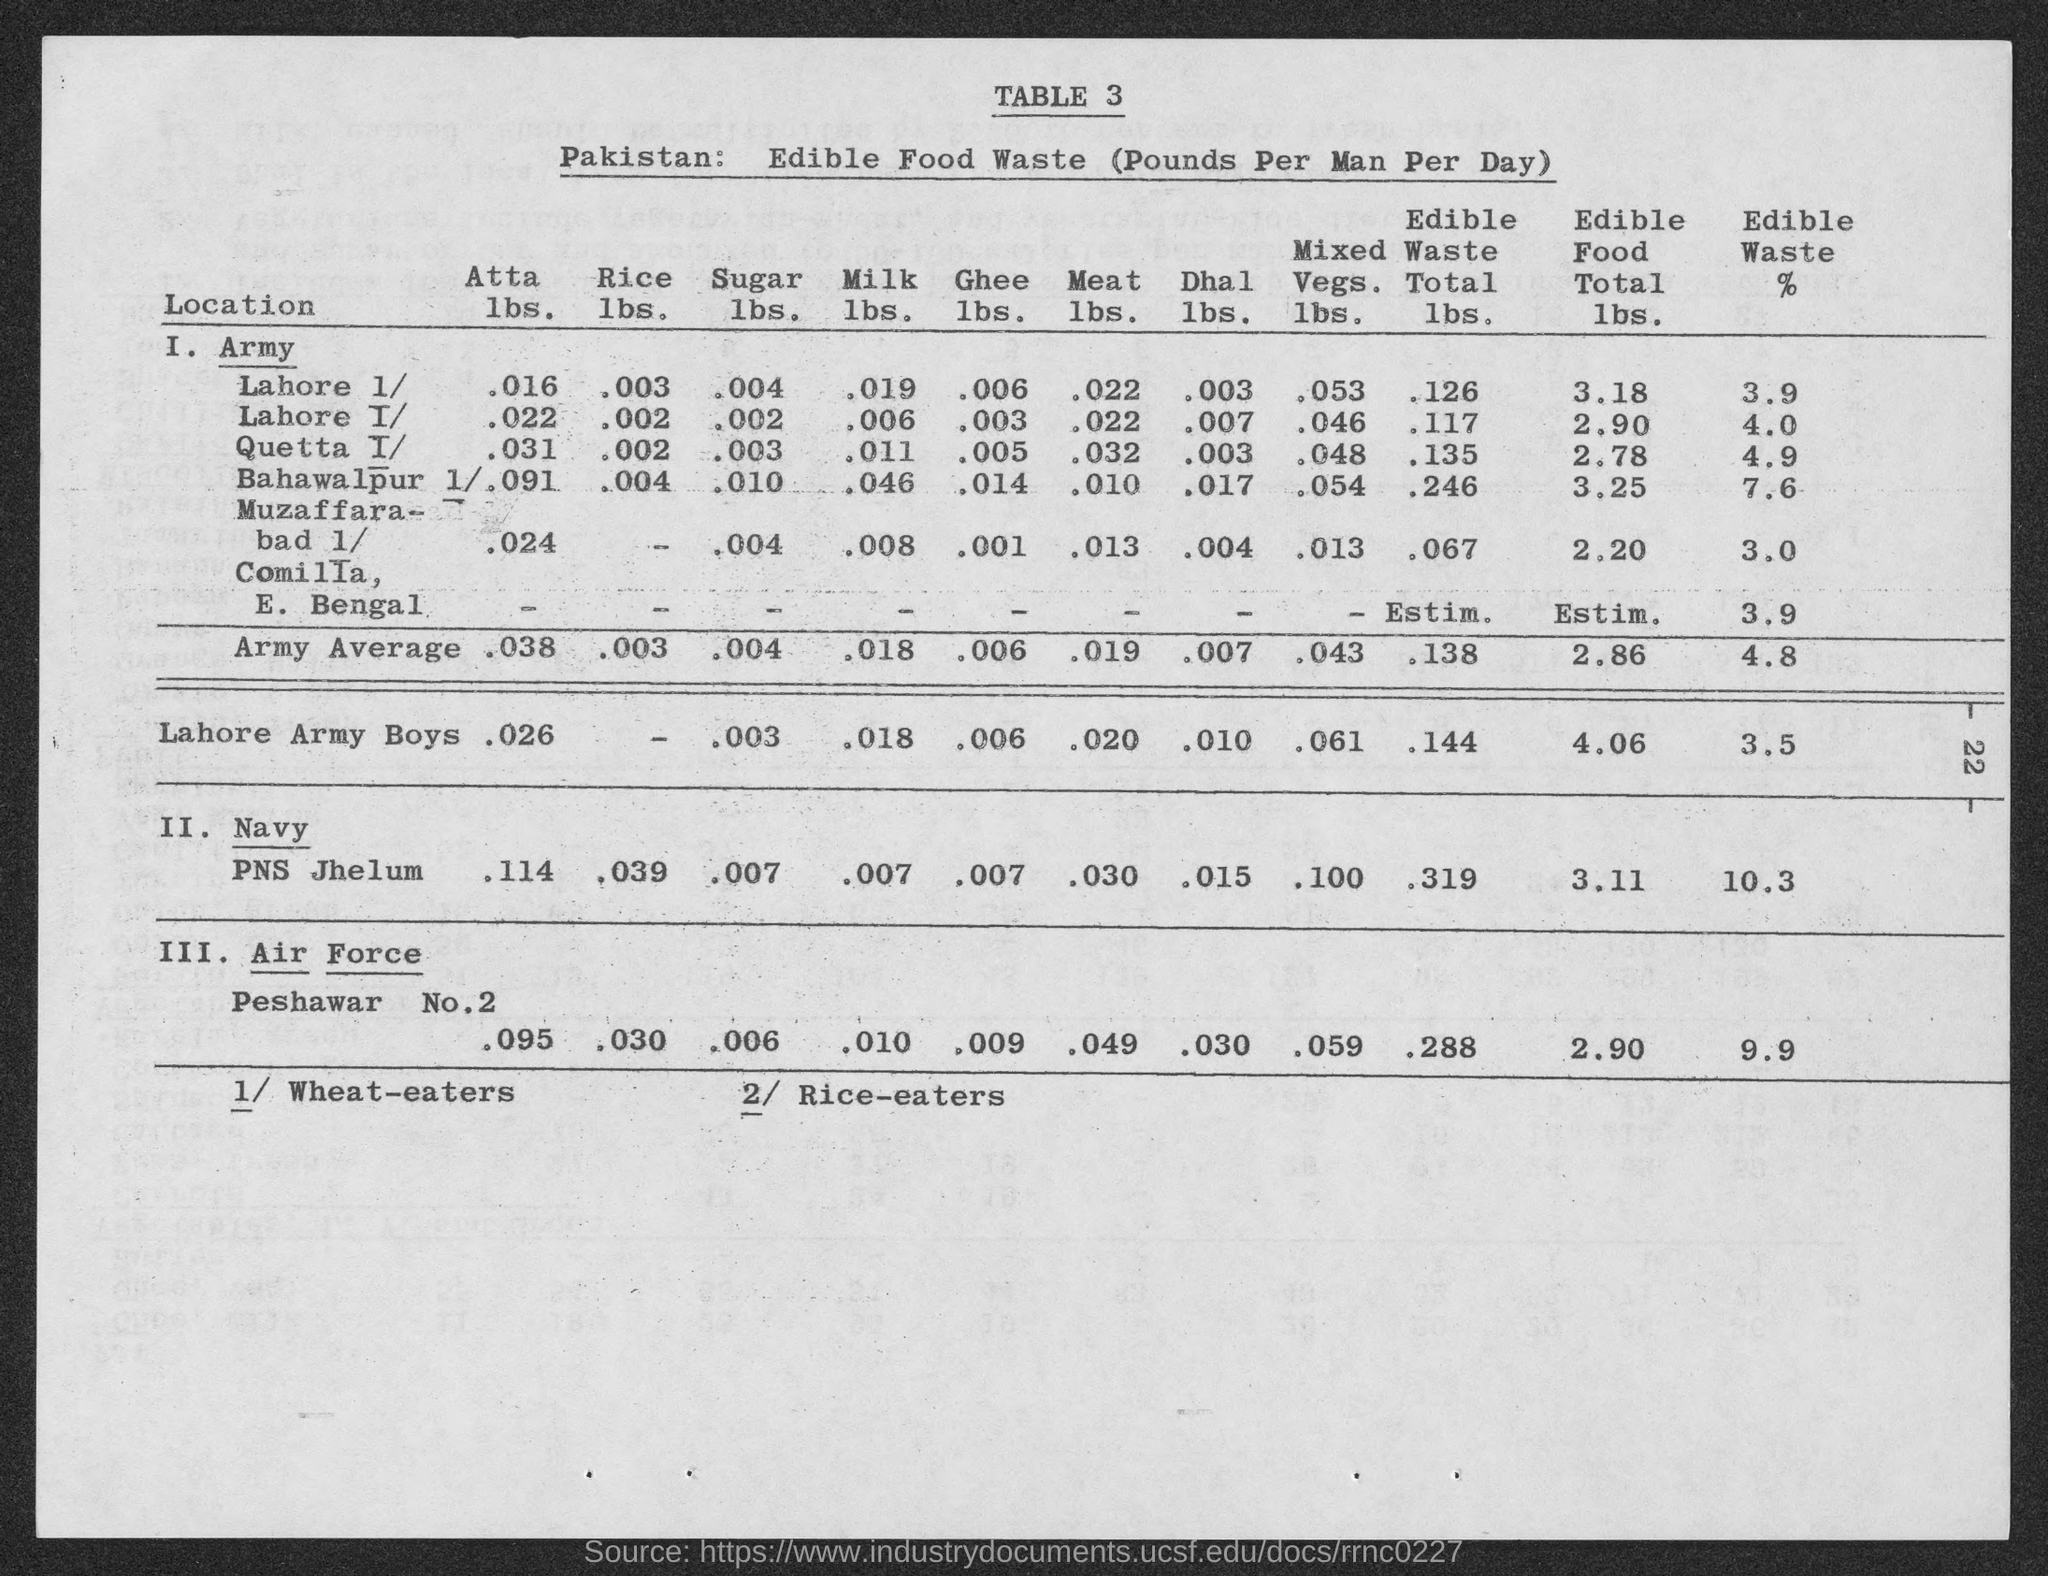What is the title of table 3?
Your answer should be very brief. Pakistan: Edible Food Waste (Pounds per Man per Day). What is the unit of edible food waste?
Offer a terse response. Pounds Per Man Per Day. 